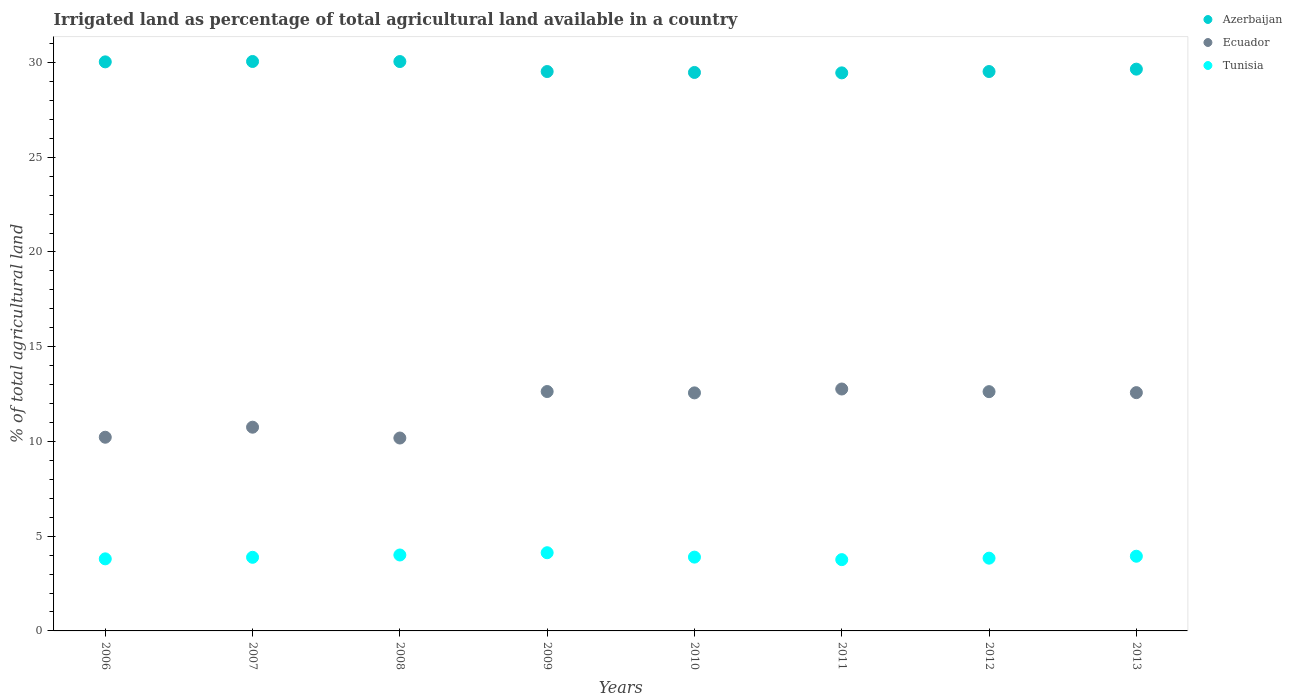How many different coloured dotlines are there?
Ensure brevity in your answer.  3. What is the percentage of irrigated land in Tunisia in 2006?
Your answer should be very brief. 3.8. Across all years, what is the maximum percentage of irrigated land in Azerbaijan?
Your answer should be very brief. 30.06. Across all years, what is the minimum percentage of irrigated land in Azerbaijan?
Your response must be concise. 29.45. What is the total percentage of irrigated land in Ecuador in the graph?
Your answer should be very brief. 94.33. What is the difference between the percentage of irrigated land in Azerbaijan in 2007 and that in 2010?
Provide a short and direct response. 0.58. What is the difference between the percentage of irrigated land in Tunisia in 2011 and the percentage of irrigated land in Ecuador in 2008?
Provide a succinct answer. -6.42. What is the average percentage of irrigated land in Ecuador per year?
Provide a succinct answer. 11.79. In the year 2013, what is the difference between the percentage of irrigated land in Tunisia and percentage of irrigated land in Ecuador?
Offer a terse response. -8.63. What is the ratio of the percentage of irrigated land in Azerbaijan in 2010 to that in 2011?
Ensure brevity in your answer.  1. Is the percentage of irrigated land in Azerbaijan in 2011 less than that in 2012?
Offer a terse response. Yes. What is the difference between the highest and the second highest percentage of irrigated land in Ecuador?
Keep it short and to the point. 0.13. What is the difference between the highest and the lowest percentage of irrigated land in Tunisia?
Give a very brief answer. 0.36. Is it the case that in every year, the sum of the percentage of irrigated land in Tunisia and percentage of irrigated land in Ecuador  is greater than the percentage of irrigated land in Azerbaijan?
Offer a terse response. No. Does the percentage of irrigated land in Azerbaijan monotonically increase over the years?
Your response must be concise. No. Is the percentage of irrigated land in Ecuador strictly greater than the percentage of irrigated land in Tunisia over the years?
Your answer should be compact. Yes. Is the percentage of irrigated land in Azerbaijan strictly less than the percentage of irrigated land in Tunisia over the years?
Your response must be concise. No. How many years are there in the graph?
Make the answer very short. 8. What is the difference between two consecutive major ticks on the Y-axis?
Keep it short and to the point. 5. Does the graph contain any zero values?
Make the answer very short. No. How many legend labels are there?
Provide a succinct answer. 3. How are the legend labels stacked?
Offer a very short reply. Vertical. What is the title of the graph?
Ensure brevity in your answer.  Irrigated land as percentage of total agricultural land available in a country. Does "Guatemala" appear as one of the legend labels in the graph?
Give a very brief answer. No. What is the label or title of the Y-axis?
Ensure brevity in your answer.  % of total agricultural land. What is the % of total agricultural land of Azerbaijan in 2006?
Offer a terse response. 30.04. What is the % of total agricultural land of Ecuador in 2006?
Provide a succinct answer. 10.22. What is the % of total agricultural land in Tunisia in 2006?
Make the answer very short. 3.8. What is the % of total agricultural land of Azerbaijan in 2007?
Keep it short and to the point. 30.06. What is the % of total agricultural land of Ecuador in 2007?
Your answer should be compact. 10.75. What is the % of total agricultural land in Tunisia in 2007?
Offer a terse response. 3.89. What is the % of total agricultural land in Azerbaijan in 2008?
Give a very brief answer. 30.05. What is the % of total agricultural land in Ecuador in 2008?
Ensure brevity in your answer.  10.18. What is the % of total agricultural land of Tunisia in 2008?
Offer a very short reply. 4.01. What is the % of total agricultural land in Azerbaijan in 2009?
Offer a very short reply. 29.53. What is the % of total agricultural land of Ecuador in 2009?
Provide a succinct answer. 12.64. What is the % of total agricultural land of Tunisia in 2009?
Provide a short and direct response. 4.13. What is the % of total agricultural land of Azerbaijan in 2010?
Offer a terse response. 29.48. What is the % of total agricultural land in Ecuador in 2010?
Offer a very short reply. 12.56. What is the % of total agricultural land of Tunisia in 2010?
Your answer should be very brief. 3.9. What is the % of total agricultural land of Azerbaijan in 2011?
Your response must be concise. 29.45. What is the % of total agricultural land of Ecuador in 2011?
Your answer should be very brief. 12.77. What is the % of total agricultural land of Tunisia in 2011?
Provide a short and direct response. 3.76. What is the % of total agricultural land of Azerbaijan in 2012?
Make the answer very short. 29.53. What is the % of total agricultural land of Ecuador in 2012?
Your answer should be compact. 12.63. What is the % of total agricultural land of Tunisia in 2012?
Ensure brevity in your answer.  3.84. What is the % of total agricultural land in Azerbaijan in 2013?
Provide a succinct answer. 29.65. What is the % of total agricultural land in Ecuador in 2013?
Give a very brief answer. 12.58. What is the % of total agricultural land in Tunisia in 2013?
Give a very brief answer. 3.94. Across all years, what is the maximum % of total agricultural land of Azerbaijan?
Your response must be concise. 30.06. Across all years, what is the maximum % of total agricultural land of Ecuador?
Offer a very short reply. 12.77. Across all years, what is the maximum % of total agricultural land of Tunisia?
Ensure brevity in your answer.  4.13. Across all years, what is the minimum % of total agricultural land in Azerbaijan?
Give a very brief answer. 29.45. Across all years, what is the minimum % of total agricultural land of Ecuador?
Your response must be concise. 10.18. Across all years, what is the minimum % of total agricultural land of Tunisia?
Your answer should be very brief. 3.76. What is the total % of total agricultural land of Azerbaijan in the graph?
Ensure brevity in your answer.  237.78. What is the total % of total agricultural land of Ecuador in the graph?
Provide a short and direct response. 94.33. What is the total % of total agricultural land in Tunisia in the graph?
Provide a succinct answer. 31.26. What is the difference between the % of total agricultural land of Azerbaijan in 2006 and that in 2007?
Offer a very short reply. -0.02. What is the difference between the % of total agricultural land in Ecuador in 2006 and that in 2007?
Ensure brevity in your answer.  -0.53. What is the difference between the % of total agricultural land of Tunisia in 2006 and that in 2007?
Keep it short and to the point. -0.08. What is the difference between the % of total agricultural land in Azerbaijan in 2006 and that in 2008?
Ensure brevity in your answer.  -0.02. What is the difference between the % of total agricultural land of Ecuador in 2006 and that in 2008?
Your response must be concise. 0.04. What is the difference between the % of total agricultural land of Tunisia in 2006 and that in 2008?
Offer a very short reply. -0.2. What is the difference between the % of total agricultural land of Azerbaijan in 2006 and that in 2009?
Give a very brief answer. 0.51. What is the difference between the % of total agricultural land of Ecuador in 2006 and that in 2009?
Offer a very short reply. -2.41. What is the difference between the % of total agricultural land in Tunisia in 2006 and that in 2009?
Give a very brief answer. -0.32. What is the difference between the % of total agricultural land of Azerbaijan in 2006 and that in 2010?
Keep it short and to the point. 0.56. What is the difference between the % of total agricultural land in Ecuador in 2006 and that in 2010?
Your answer should be compact. -2.34. What is the difference between the % of total agricultural land of Tunisia in 2006 and that in 2010?
Make the answer very short. -0.09. What is the difference between the % of total agricultural land in Azerbaijan in 2006 and that in 2011?
Give a very brief answer. 0.58. What is the difference between the % of total agricultural land in Ecuador in 2006 and that in 2011?
Your answer should be very brief. -2.55. What is the difference between the % of total agricultural land of Tunisia in 2006 and that in 2011?
Your answer should be very brief. 0.04. What is the difference between the % of total agricultural land of Azerbaijan in 2006 and that in 2012?
Offer a very short reply. 0.51. What is the difference between the % of total agricultural land in Ecuador in 2006 and that in 2012?
Give a very brief answer. -2.41. What is the difference between the % of total agricultural land of Tunisia in 2006 and that in 2012?
Ensure brevity in your answer.  -0.04. What is the difference between the % of total agricultural land in Azerbaijan in 2006 and that in 2013?
Your answer should be compact. 0.38. What is the difference between the % of total agricultural land of Ecuador in 2006 and that in 2013?
Your answer should be very brief. -2.35. What is the difference between the % of total agricultural land in Tunisia in 2006 and that in 2013?
Keep it short and to the point. -0.14. What is the difference between the % of total agricultural land in Azerbaijan in 2007 and that in 2008?
Offer a terse response. 0. What is the difference between the % of total agricultural land in Ecuador in 2007 and that in 2008?
Provide a short and direct response. 0.57. What is the difference between the % of total agricultural land of Tunisia in 2007 and that in 2008?
Your answer should be compact. -0.12. What is the difference between the % of total agricultural land of Azerbaijan in 2007 and that in 2009?
Your response must be concise. 0.53. What is the difference between the % of total agricultural land in Ecuador in 2007 and that in 2009?
Provide a short and direct response. -1.88. What is the difference between the % of total agricultural land in Tunisia in 2007 and that in 2009?
Ensure brevity in your answer.  -0.24. What is the difference between the % of total agricultural land of Azerbaijan in 2007 and that in 2010?
Ensure brevity in your answer.  0.58. What is the difference between the % of total agricultural land in Ecuador in 2007 and that in 2010?
Offer a very short reply. -1.81. What is the difference between the % of total agricultural land of Tunisia in 2007 and that in 2010?
Your answer should be very brief. -0.01. What is the difference between the % of total agricultural land of Azerbaijan in 2007 and that in 2011?
Your answer should be very brief. 0.6. What is the difference between the % of total agricultural land in Ecuador in 2007 and that in 2011?
Your response must be concise. -2.02. What is the difference between the % of total agricultural land of Tunisia in 2007 and that in 2011?
Ensure brevity in your answer.  0.12. What is the difference between the % of total agricultural land in Azerbaijan in 2007 and that in 2012?
Your answer should be very brief. 0.53. What is the difference between the % of total agricultural land of Ecuador in 2007 and that in 2012?
Provide a short and direct response. -1.88. What is the difference between the % of total agricultural land of Tunisia in 2007 and that in 2012?
Make the answer very short. 0.05. What is the difference between the % of total agricultural land in Azerbaijan in 2007 and that in 2013?
Provide a succinct answer. 0.4. What is the difference between the % of total agricultural land in Ecuador in 2007 and that in 2013?
Offer a very short reply. -1.82. What is the difference between the % of total agricultural land of Tunisia in 2007 and that in 2013?
Offer a terse response. -0.06. What is the difference between the % of total agricultural land in Azerbaijan in 2008 and that in 2009?
Provide a succinct answer. 0.53. What is the difference between the % of total agricultural land in Ecuador in 2008 and that in 2009?
Offer a very short reply. -2.45. What is the difference between the % of total agricultural land of Tunisia in 2008 and that in 2009?
Provide a short and direct response. -0.12. What is the difference between the % of total agricultural land in Azerbaijan in 2008 and that in 2010?
Keep it short and to the point. 0.58. What is the difference between the % of total agricultural land in Ecuador in 2008 and that in 2010?
Your answer should be very brief. -2.38. What is the difference between the % of total agricultural land of Tunisia in 2008 and that in 2010?
Make the answer very short. 0.11. What is the difference between the % of total agricultural land in Azerbaijan in 2008 and that in 2011?
Ensure brevity in your answer.  0.6. What is the difference between the % of total agricultural land of Ecuador in 2008 and that in 2011?
Your answer should be very brief. -2.59. What is the difference between the % of total agricultural land of Tunisia in 2008 and that in 2011?
Provide a short and direct response. 0.24. What is the difference between the % of total agricultural land of Azerbaijan in 2008 and that in 2012?
Ensure brevity in your answer.  0.53. What is the difference between the % of total agricultural land in Ecuador in 2008 and that in 2012?
Your answer should be very brief. -2.45. What is the difference between the % of total agricultural land of Tunisia in 2008 and that in 2012?
Give a very brief answer. 0.17. What is the difference between the % of total agricultural land of Azerbaijan in 2008 and that in 2013?
Give a very brief answer. 0.4. What is the difference between the % of total agricultural land of Ecuador in 2008 and that in 2013?
Offer a terse response. -2.4. What is the difference between the % of total agricultural land in Tunisia in 2008 and that in 2013?
Provide a short and direct response. 0.07. What is the difference between the % of total agricultural land in Azerbaijan in 2009 and that in 2010?
Ensure brevity in your answer.  0.05. What is the difference between the % of total agricultural land of Ecuador in 2009 and that in 2010?
Keep it short and to the point. 0.07. What is the difference between the % of total agricultural land of Tunisia in 2009 and that in 2010?
Ensure brevity in your answer.  0.23. What is the difference between the % of total agricultural land of Azerbaijan in 2009 and that in 2011?
Offer a terse response. 0.07. What is the difference between the % of total agricultural land in Ecuador in 2009 and that in 2011?
Offer a very short reply. -0.13. What is the difference between the % of total agricultural land of Tunisia in 2009 and that in 2011?
Your answer should be compact. 0.36. What is the difference between the % of total agricultural land of Azerbaijan in 2009 and that in 2012?
Keep it short and to the point. -0. What is the difference between the % of total agricultural land in Ecuador in 2009 and that in 2012?
Make the answer very short. 0.01. What is the difference between the % of total agricultural land in Tunisia in 2009 and that in 2012?
Your answer should be very brief. 0.29. What is the difference between the % of total agricultural land of Azerbaijan in 2009 and that in 2013?
Ensure brevity in your answer.  -0.13. What is the difference between the % of total agricultural land of Ecuador in 2009 and that in 2013?
Make the answer very short. 0.06. What is the difference between the % of total agricultural land in Tunisia in 2009 and that in 2013?
Your answer should be compact. 0.18. What is the difference between the % of total agricultural land in Azerbaijan in 2010 and that in 2011?
Provide a short and direct response. 0.02. What is the difference between the % of total agricultural land in Ecuador in 2010 and that in 2011?
Your response must be concise. -0.2. What is the difference between the % of total agricultural land of Tunisia in 2010 and that in 2011?
Your answer should be compact. 0.13. What is the difference between the % of total agricultural land of Azerbaijan in 2010 and that in 2012?
Make the answer very short. -0.05. What is the difference between the % of total agricultural land of Ecuador in 2010 and that in 2012?
Provide a short and direct response. -0.06. What is the difference between the % of total agricultural land in Tunisia in 2010 and that in 2012?
Make the answer very short. 0.06. What is the difference between the % of total agricultural land in Azerbaijan in 2010 and that in 2013?
Offer a very short reply. -0.17. What is the difference between the % of total agricultural land in Ecuador in 2010 and that in 2013?
Ensure brevity in your answer.  -0.01. What is the difference between the % of total agricultural land in Tunisia in 2010 and that in 2013?
Offer a very short reply. -0.05. What is the difference between the % of total agricultural land in Azerbaijan in 2011 and that in 2012?
Make the answer very short. -0.07. What is the difference between the % of total agricultural land of Ecuador in 2011 and that in 2012?
Your answer should be compact. 0.14. What is the difference between the % of total agricultural land in Tunisia in 2011 and that in 2012?
Keep it short and to the point. -0.08. What is the difference between the % of total agricultural land of Azerbaijan in 2011 and that in 2013?
Make the answer very short. -0.2. What is the difference between the % of total agricultural land of Ecuador in 2011 and that in 2013?
Ensure brevity in your answer.  0.19. What is the difference between the % of total agricultural land in Tunisia in 2011 and that in 2013?
Give a very brief answer. -0.18. What is the difference between the % of total agricultural land in Azerbaijan in 2012 and that in 2013?
Your answer should be very brief. -0.12. What is the difference between the % of total agricultural land in Ecuador in 2012 and that in 2013?
Your answer should be very brief. 0.05. What is the difference between the % of total agricultural land of Tunisia in 2012 and that in 2013?
Your response must be concise. -0.1. What is the difference between the % of total agricultural land of Azerbaijan in 2006 and the % of total agricultural land of Ecuador in 2007?
Your answer should be very brief. 19.28. What is the difference between the % of total agricultural land in Azerbaijan in 2006 and the % of total agricultural land in Tunisia in 2007?
Give a very brief answer. 26.15. What is the difference between the % of total agricultural land in Ecuador in 2006 and the % of total agricultural land in Tunisia in 2007?
Your response must be concise. 6.34. What is the difference between the % of total agricultural land of Azerbaijan in 2006 and the % of total agricultural land of Ecuador in 2008?
Ensure brevity in your answer.  19.85. What is the difference between the % of total agricultural land in Azerbaijan in 2006 and the % of total agricultural land in Tunisia in 2008?
Offer a terse response. 26.03. What is the difference between the % of total agricultural land in Ecuador in 2006 and the % of total agricultural land in Tunisia in 2008?
Offer a terse response. 6.22. What is the difference between the % of total agricultural land of Azerbaijan in 2006 and the % of total agricultural land of Ecuador in 2009?
Your response must be concise. 17.4. What is the difference between the % of total agricultural land in Azerbaijan in 2006 and the % of total agricultural land in Tunisia in 2009?
Offer a very short reply. 25.91. What is the difference between the % of total agricultural land of Ecuador in 2006 and the % of total agricultural land of Tunisia in 2009?
Provide a succinct answer. 6.1. What is the difference between the % of total agricultural land of Azerbaijan in 2006 and the % of total agricultural land of Ecuador in 2010?
Keep it short and to the point. 17.47. What is the difference between the % of total agricultural land in Azerbaijan in 2006 and the % of total agricultural land in Tunisia in 2010?
Provide a short and direct response. 26.14. What is the difference between the % of total agricultural land of Ecuador in 2006 and the % of total agricultural land of Tunisia in 2010?
Make the answer very short. 6.33. What is the difference between the % of total agricultural land in Azerbaijan in 2006 and the % of total agricultural land in Ecuador in 2011?
Provide a succinct answer. 17.27. What is the difference between the % of total agricultural land in Azerbaijan in 2006 and the % of total agricultural land in Tunisia in 2011?
Offer a terse response. 26.27. What is the difference between the % of total agricultural land of Ecuador in 2006 and the % of total agricultural land of Tunisia in 2011?
Provide a succinct answer. 6.46. What is the difference between the % of total agricultural land in Azerbaijan in 2006 and the % of total agricultural land in Ecuador in 2012?
Your answer should be very brief. 17.41. What is the difference between the % of total agricultural land in Azerbaijan in 2006 and the % of total agricultural land in Tunisia in 2012?
Your answer should be compact. 26.2. What is the difference between the % of total agricultural land of Ecuador in 2006 and the % of total agricultural land of Tunisia in 2012?
Offer a very short reply. 6.38. What is the difference between the % of total agricultural land in Azerbaijan in 2006 and the % of total agricultural land in Ecuador in 2013?
Your answer should be compact. 17.46. What is the difference between the % of total agricultural land in Azerbaijan in 2006 and the % of total agricultural land in Tunisia in 2013?
Your answer should be compact. 26.09. What is the difference between the % of total agricultural land of Ecuador in 2006 and the % of total agricultural land of Tunisia in 2013?
Keep it short and to the point. 6.28. What is the difference between the % of total agricultural land in Azerbaijan in 2007 and the % of total agricultural land in Ecuador in 2008?
Make the answer very short. 19.87. What is the difference between the % of total agricultural land in Azerbaijan in 2007 and the % of total agricultural land in Tunisia in 2008?
Keep it short and to the point. 26.05. What is the difference between the % of total agricultural land in Ecuador in 2007 and the % of total agricultural land in Tunisia in 2008?
Give a very brief answer. 6.75. What is the difference between the % of total agricultural land of Azerbaijan in 2007 and the % of total agricultural land of Ecuador in 2009?
Provide a succinct answer. 17.42. What is the difference between the % of total agricultural land in Azerbaijan in 2007 and the % of total agricultural land in Tunisia in 2009?
Your answer should be very brief. 25.93. What is the difference between the % of total agricultural land of Ecuador in 2007 and the % of total agricultural land of Tunisia in 2009?
Give a very brief answer. 6.63. What is the difference between the % of total agricultural land in Azerbaijan in 2007 and the % of total agricultural land in Ecuador in 2010?
Keep it short and to the point. 17.49. What is the difference between the % of total agricultural land in Azerbaijan in 2007 and the % of total agricultural land in Tunisia in 2010?
Provide a succinct answer. 26.16. What is the difference between the % of total agricultural land of Ecuador in 2007 and the % of total agricultural land of Tunisia in 2010?
Offer a very short reply. 6.86. What is the difference between the % of total agricultural land in Azerbaijan in 2007 and the % of total agricultural land in Ecuador in 2011?
Offer a very short reply. 17.29. What is the difference between the % of total agricultural land in Azerbaijan in 2007 and the % of total agricultural land in Tunisia in 2011?
Your answer should be compact. 26.29. What is the difference between the % of total agricultural land of Ecuador in 2007 and the % of total agricultural land of Tunisia in 2011?
Your answer should be compact. 6.99. What is the difference between the % of total agricultural land in Azerbaijan in 2007 and the % of total agricultural land in Ecuador in 2012?
Make the answer very short. 17.43. What is the difference between the % of total agricultural land in Azerbaijan in 2007 and the % of total agricultural land in Tunisia in 2012?
Provide a succinct answer. 26.22. What is the difference between the % of total agricultural land in Ecuador in 2007 and the % of total agricultural land in Tunisia in 2012?
Make the answer very short. 6.91. What is the difference between the % of total agricultural land in Azerbaijan in 2007 and the % of total agricultural land in Ecuador in 2013?
Ensure brevity in your answer.  17.48. What is the difference between the % of total agricultural land of Azerbaijan in 2007 and the % of total agricultural land of Tunisia in 2013?
Offer a very short reply. 26.11. What is the difference between the % of total agricultural land in Ecuador in 2007 and the % of total agricultural land in Tunisia in 2013?
Offer a terse response. 6.81. What is the difference between the % of total agricultural land of Azerbaijan in 2008 and the % of total agricultural land of Ecuador in 2009?
Give a very brief answer. 17.42. What is the difference between the % of total agricultural land of Azerbaijan in 2008 and the % of total agricultural land of Tunisia in 2009?
Your response must be concise. 25.93. What is the difference between the % of total agricultural land of Ecuador in 2008 and the % of total agricultural land of Tunisia in 2009?
Offer a very short reply. 6.05. What is the difference between the % of total agricultural land of Azerbaijan in 2008 and the % of total agricultural land of Ecuador in 2010?
Provide a succinct answer. 17.49. What is the difference between the % of total agricultural land in Azerbaijan in 2008 and the % of total agricultural land in Tunisia in 2010?
Offer a terse response. 26.16. What is the difference between the % of total agricultural land of Ecuador in 2008 and the % of total agricultural land of Tunisia in 2010?
Offer a very short reply. 6.29. What is the difference between the % of total agricultural land of Azerbaijan in 2008 and the % of total agricultural land of Ecuador in 2011?
Make the answer very short. 17.28. What is the difference between the % of total agricultural land in Azerbaijan in 2008 and the % of total agricultural land in Tunisia in 2011?
Keep it short and to the point. 26.29. What is the difference between the % of total agricultural land in Ecuador in 2008 and the % of total agricultural land in Tunisia in 2011?
Keep it short and to the point. 6.42. What is the difference between the % of total agricultural land in Azerbaijan in 2008 and the % of total agricultural land in Ecuador in 2012?
Offer a very short reply. 17.42. What is the difference between the % of total agricultural land in Azerbaijan in 2008 and the % of total agricultural land in Tunisia in 2012?
Offer a terse response. 26.21. What is the difference between the % of total agricultural land in Ecuador in 2008 and the % of total agricultural land in Tunisia in 2012?
Make the answer very short. 6.34. What is the difference between the % of total agricultural land in Azerbaijan in 2008 and the % of total agricultural land in Ecuador in 2013?
Ensure brevity in your answer.  17.48. What is the difference between the % of total agricultural land of Azerbaijan in 2008 and the % of total agricultural land of Tunisia in 2013?
Keep it short and to the point. 26.11. What is the difference between the % of total agricultural land in Ecuador in 2008 and the % of total agricultural land in Tunisia in 2013?
Make the answer very short. 6.24. What is the difference between the % of total agricultural land of Azerbaijan in 2009 and the % of total agricultural land of Ecuador in 2010?
Ensure brevity in your answer.  16.96. What is the difference between the % of total agricultural land of Azerbaijan in 2009 and the % of total agricultural land of Tunisia in 2010?
Provide a succinct answer. 25.63. What is the difference between the % of total agricultural land in Ecuador in 2009 and the % of total agricultural land in Tunisia in 2010?
Your answer should be very brief. 8.74. What is the difference between the % of total agricultural land of Azerbaijan in 2009 and the % of total agricultural land of Ecuador in 2011?
Give a very brief answer. 16.76. What is the difference between the % of total agricultural land of Azerbaijan in 2009 and the % of total agricultural land of Tunisia in 2011?
Your answer should be compact. 25.76. What is the difference between the % of total agricultural land of Ecuador in 2009 and the % of total agricultural land of Tunisia in 2011?
Your response must be concise. 8.87. What is the difference between the % of total agricultural land in Azerbaijan in 2009 and the % of total agricultural land in Ecuador in 2012?
Your answer should be very brief. 16.9. What is the difference between the % of total agricultural land of Azerbaijan in 2009 and the % of total agricultural land of Tunisia in 2012?
Offer a terse response. 25.69. What is the difference between the % of total agricultural land in Ecuador in 2009 and the % of total agricultural land in Tunisia in 2012?
Offer a terse response. 8.8. What is the difference between the % of total agricultural land in Azerbaijan in 2009 and the % of total agricultural land in Ecuador in 2013?
Offer a terse response. 16.95. What is the difference between the % of total agricultural land of Azerbaijan in 2009 and the % of total agricultural land of Tunisia in 2013?
Offer a terse response. 25.58. What is the difference between the % of total agricultural land of Ecuador in 2009 and the % of total agricultural land of Tunisia in 2013?
Your response must be concise. 8.69. What is the difference between the % of total agricultural land of Azerbaijan in 2010 and the % of total agricultural land of Ecuador in 2011?
Your answer should be compact. 16.71. What is the difference between the % of total agricultural land in Azerbaijan in 2010 and the % of total agricultural land in Tunisia in 2011?
Your response must be concise. 25.71. What is the difference between the % of total agricultural land in Ecuador in 2010 and the % of total agricultural land in Tunisia in 2011?
Your answer should be very brief. 8.8. What is the difference between the % of total agricultural land in Azerbaijan in 2010 and the % of total agricultural land in Ecuador in 2012?
Keep it short and to the point. 16.85. What is the difference between the % of total agricultural land of Azerbaijan in 2010 and the % of total agricultural land of Tunisia in 2012?
Make the answer very short. 25.64. What is the difference between the % of total agricultural land of Ecuador in 2010 and the % of total agricultural land of Tunisia in 2012?
Your answer should be compact. 8.72. What is the difference between the % of total agricultural land in Azerbaijan in 2010 and the % of total agricultural land in Ecuador in 2013?
Your answer should be compact. 16.9. What is the difference between the % of total agricultural land in Azerbaijan in 2010 and the % of total agricultural land in Tunisia in 2013?
Your response must be concise. 25.53. What is the difference between the % of total agricultural land of Ecuador in 2010 and the % of total agricultural land of Tunisia in 2013?
Offer a terse response. 8.62. What is the difference between the % of total agricultural land of Azerbaijan in 2011 and the % of total agricultural land of Ecuador in 2012?
Offer a very short reply. 16.83. What is the difference between the % of total agricultural land in Azerbaijan in 2011 and the % of total agricultural land in Tunisia in 2012?
Give a very brief answer. 25.61. What is the difference between the % of total agricultural land of Ecuador in 2011 and the % of total agricultural land of Tunisia in 2012?
Offer a terse response. 8.93. What is the difference between the % of total agricultural land in Azerbaijan in 2011 and the % of total agricultural land in Ecuador in 2013?
Ensure brevity in your answer.  16.88. What is the difference between the % of total agricultural land of Azerbaijan in 2011 and the % of total agricultural land of Tunisia in 2013?
Offer a very short reply. 25.51. What is the difference between the % of total agricultural land of Ecuador in 2011 and the % of total agricultural land of Tunisia in 2013?
Offer a terse response. 8.83. What is the difference between the % of total agricultural land of Azerbaijan in 2012 and the % of total agricultural land of Ecuador in 2013?
Provide a short and direct response. 16.95. What is the difference between the % of total agricultural land of Azerbaijan in 2012 and the % of total agricultural land of Tunisia in 2013?
Your answer should be very brief. 25.58. What is the difference between the % of total agricultural land in Ecuador in 2012 and the % of total agricultural land in Tunisia in 2013?
Your response must be concise. 8.69. What is the average % of total agricultural land of Azerbaijan per year?
Your response must be concise. 29.72. What is the average % of total agricultural land in Ecuador per year?
Offer a terse response. 11.79. What is the average % of total agricultural land in Tunisia per year?
Provide a short and direct response. 3.91. In the year 2006, what is the difference between the % of total agricultural land in Azerbaijan and % of total agricultural land in Ecuador?
Your response must be concise. 19.81. In the year 2006, what is the difference between the % of total agricultural land in Azerbaijan and % of total agricultural land in Tunisia?
Give a very brief answer. 26.23. In the year 2006, what is the difference between the % of total agricultural land in Ecuador and % of total agricultural land in Tunisia?
Your answer should be compact. 6.42. In the year 2007, what is the difference between the % of total agricultural land in Azerbaijan and % of total agricultural land in Ecuador?
Offer a very short reply. 19.3. In the year 2007, what is the difference between the % of total agricultural land in Azerbaijan and % of total agricultural land in Tunisia?
Provide a short and direct response. 26.17. In the year 2007, what is the difference between the % of total agricultural land of Ecuador and % of total agricultural land of Tunisia?
Provide a succinct answer. 6.87. In the year 2008, what is the difference between the % of total agricultural land in Azerbaijan and % of total agricultural land in Ecuador?
Offer a terse response. 19.87. In the year 2008, what is the difference between the % of total agricultural land of Azerbaijan and % of total agricultural land of Tunisia?
Make the answer very short. 26.04. In the year 2008, what is the difference between the % of total agricultural land in Ecuador and % of total agricultural land in Tunisia?
Give a very brief answer. 6.17. In the year 2009, what is the difference between the % of total agricultural land in Azerbaijan and % of total agricultural land in Ecuador?
Give a very brief answer. 16.89. In the year 2009, what is the difference between the % of total agricultural land in Azerbaijan and % of total agricultural land in Tunisia?
Offer a very short reply. 25.4. In the year 2009, what is the difference between the % of total agricultural land in Ecuador and % of total agricultural land in Tunisia?
Offer a very short reply. 8.51. In the year 2010, what is the difference between the % of total agricultural land in Azerbaijan and % of total agricultural land in Ecuador?
Offer a terse response. 16.91. In the year 2010, what is the difference between the % of total agricultural land of Azerbaijan and % of total agricultural land of Tunisia?
Your answer should be very brief. 25.58. In the year 2010, what is the difference between the % of total agricultural land of Ecuador and % of total agricultural land of Tunisia?
Your answer should be compact. 8.67. In the year 2011, what is the difference between the % of total agricultural land of Azerbaijan and % of total agricultural land of Ecuador?
Ensure brevity in your answer.  16.69. In the year 2011, what is the difference between the % of total agricultural land of Azerbaijan and % of total agricultural land of Tunisia?
Offer a terse response. 25.69. In the year 2011, what is the difference between the % of total agricultural land in Ecuador and % of total agricultural land in Tunisia?
Keep it short and to the point. 9.01. In the year 2012, what is the difference between the % of total agricultural land in Azerbaijan and % of total agricultural land in Ecuador?
Offer a terse response. 16.9. In the year 2012, what is the difference between the % of total agricultural land of Azerbaijan and % of total agricultural land of Tunisia?
Your answer should be very brief. 25.69. In the year 2012, what is the difference between the % of total agricultural land of Ecuador and % of total agricultural land of Tunisia?
Your answer should be compact. 8.79. In the year 2013, what is the difference between the % of total agricultural land in Azerbaijan and % of total agricultural land in Ecuador?
Your response must be concise. 17.07. In the year 2013, what is the difference between the % of total agricultural land of Azerbaijan and % of total agricultural land of Tunisia?
Your response must be concise. 25.71. In the year 2013, what is the difference between the % of total agricultural land of Ecuador and % of total agricultural land of Tunisia?
Provide a short and direct response. 8.63. What is the ratio of the % of total agricultural land in Ecuador in 2006 to that in 2007?
Make the answer very short. 0.95. What is the ratio of the % of total agricultural land in Tunisia in 2006 to that in 2007?
Your answer should be compact. 0.98. What is the ratio of the % of total agricultural land of Azerbaijan in 2006 to that in 2008?
Provide a short and direct response. 1. What is the ratio of the % of total agricultural land in Ecuador in 2006 to that in 2008?
Give a very brief answer. 1. What is the ratio of the % of total agricultural land in Tunisia in 2006 to that in 2008?
Your answer should be compact. 0.95. What is the ratio of the % of total agricultural land in Azerbaijan in 2006 to that in 2009?
Give a very brief answer. 1.02. What is the ratio of the % of total agricultural land of Ecuador in 2006 to that in 2009?
Provide a succinct answer. 0.81. What is the ratio of the % of total agricultural land in Tunisia in 2006 to that in 2009?
Give a very brief answer. 0.92. What is the ratio of the % of total agricultural land in Ecuador in 2006 to that in 2010?
Your answer should be very brief. 0.81. What is the ratio of the % of total agricultural land of Tunisia in 2006 to that in 2010?
Offer a terse response. 0.98. What is the ratio of the % of total agricultural land of Azerbaijan in 2006 to that in 2011?
Offer a terse response. 1.02. What is the ratio of the % of total agricultural land in Ecuador in 2006 to that in 2011?
Your response must be concise. 0.8. What is the ratio of the % of total agricultural land of Tunisia in 2006 to that in 2011?
Your response must be concise. 1.01. What is the ratio of the % of total agricultural land of Azerbaijan in 2006 to that in 2012?
Provide a succinct answer. 1.02. What is the ratio of the % of total agricultural land in Ecuador in 2006 to that in 2012?
Offer a terse response. 0.81. What is the ratio of the % of total agricultural land in Tunisia in 2006 to that in 2012?
Keep it short and to the point. 0.99. What is the ratio of the % of total agricultural land in Azerbaijan in 2006 to that in 2013?
Provide a short and direct response. 1.01. What is the ratio of the % of total agricultural land of Ecuador in 2006 to that in 2013?
Your response must be concise. 0.81. What is the ratio of the % of total agricultural land of Tunisia in 2006 to that in 2013?
Your answer should be very brief. 0.96. What is the ratio of the % of total agricultural land of Azerbaijan in 2007 to that in 2008?
Keep it short and to the point. 1. What is the ratio of the % of total agricultural land in Ecuador in 2007 to that in 2008?
Provide a short and direct response. 1.06. What is the ratio of the % of total agricultural land of Tunisia in 2007 to that in 2008?
Your answer should be very brief. 0.97. What is the ratio of the % of total agricultural land in Azerbaijan in 2007 to that in 2009?
Offer a very short reply. 1.02. What is the ratio of the % of total agricultural land in Ecuador in 2007 to that in 2009?
Offer a very short reply. 0.85. What is the ratio of the % of total agricultural land of Tunisia in 2007 to that in 2009?
Keep it short and to the point. 0.94. What is the ratio of the % of total agricultural land of Azerbaijan in 2007 to that in 2010?
Provide a succinct answer. 1.02. What is the ratio of the % of total agricultural land of Ecuador in 2007 to that in 2010?
Offer a very short reply. 0.86. What is the ratio of the % of total agricultural land in Tunisia in 2007 to that in 2010?
Ensure brevity in your answer.  1. What is the ratio of the % of total agricultural land in Azerbaijan in 2007 to that in 2011?
Offer a terse response. 1.02. What is the ratio of the % of total agricultural land of Ecuador in 2007 to that in 2011?
Keep it short and to the point. 0.84. What is the ratio of the % of total agricultural land of Tunisia in 2007 to that in 2011?
Give a very brief answer. 1.03. What is the ratio of the % of total agricultural land of Azerbaijan in 2007 to that in 2012?
Provide a short and direct response. 1.02. What is the ratio of the % of total agricultural land of Ecuador in 2007 to that in 2012?
Your response must be concise. 0.85. What is the ratio of the % of total agricultural land of Tunisia in 2007 to that in 2012?
Make the answer very short. 1.01. What is the ratio of the % of total agricultural land in Azerbaijan in 2007 to that in 2013?
Provide a short and direct response. 1.01. What is the ratio of the % of total agricultural land in Ecuador in 2007 to that in 2013?
Provide a short and direct response. 0.85. What is the ratio of the % of total agricultural land of Tunisia in 2007 to that in 2013?
Offer a terse response. 0.99. What is the ratio of the % of total agricultural land of Azerbaijan in 2008 to that in 2009?
Provide a short and direct response. 1.02. What is the ratio of the % of total agricultural land of Ecuador in 2008 to that in 2009?
Keep it short and to the point. 0.81. What is the ratio of the % of total agricultural land in Tunisia in 2008 to that in 2009?
Ensure brevity in your answer.  0.97. What is the ratio of the % of total agricultural land of Azerbaijan in 2008 to that in 2010?
Provide a succinct answer. 1.02. What is the ratio of the % of total agricultural land in Ecuador in 2008 to that in 2010?
Ensure brevity in your answer.  0.81. What is the ratio of the % of total agricultural land of Tunisia in 2008 to that in 2010?
Provide a succinct answer. 1.03. What is the ratio of the % of total agricultural land of Azerbaijan in 2008 to that in 2011?
Your response must be concise. 1.02. What is the ratio of the % of total agricultural land in Ecuador in 2008 to that in 2011?
Ensure brevity in your answer.  0.8. What is the ratio of the % of total agricultural land of Tunisia in 2008 to that in 2011?
Provide a short and direct response. 1.07. What is the ratio of the % of total agricultural land in Azerbaijan in 2008 to that in 2012?
Provide a short and direct response. 1.02. What is the ratio of the % of total agricultural land in Ecuador in 2008 to that in 2012?
Your response must be concise. 0.81. What is the ratio of the % of total agricultural land of Tunisia in 2008 to that in 2012?
Your answer should be compact. 1.04. What is the ratio of the % of total agricultural land of Azerbaijan in 2008 to that in 2013?
Your answer should be compact. 1.01. What is the ratio of the % of total agricultural land of Ecuador in 2008 to that in 2013?
Provide a short and direct response. 0.81. What is the ratio of the % of total agricultural land in Tunisia in 2008 to that in 2013?
Your answer should be compact. 1.02. What is the ratio of the % of total agricultural land of Azerbaijan in 2009 to that in 2010?
Provide a short and direct response. 1. What is the ratio of the % of total agricultural land in Tunisia in 2009 to that in 2010?
Make the answer very short. 1.06. What is the ratio of the % of total agricultural land in Azerbaijan in 2009 to that in 2011?
Your answer should be very brief. 1. What is the ratio of the % of total agricultural land in Tunisia in 2009 to that in 2011?
Your answer should be very brief. 1.1. What is the ratio of the % of total agricultural land in Azerbaijan in 2009 to that in 2012?
Offer a terse response. 1. What is the ratio of the % of total agricultural land in Tunisia in 2009 to that in 2012?
Your answer should be very brief. 1.07. What is the ratio of the % of total agricultural land in Ecuador in 2009 to that in 2013?
Ensure brevity in your answer.  1. What is the ratio of the % of total agricultural land of Tunisia in 2009 to that in 2013?
Ensure brevity in your answer.  1.05. What is the ratio of the % of total agricultural land in Azerbaijan in 2010 to that in 2011?
Make the answer very short. 1. What is the ratio of the % of total agricultural land of Tunisia in 2010 to that in 2011?
Make the answer very short. 1.04. What is the ratio of the % of total agricultural land in Azerbaijan in 2010 to that in 2012?
Your answer should be very brief. 1. What is the ratio of the % of total agricultural land of Tunisia in 2010 to that in 2012?
Your response must be concise. 1.01. What is the ratio of the % of total agricultural land in Azerbaijan in 2011 to that in 2012?
Your answer should be compact. 1. What is the ratio of the % of total agricultural land in Ecuador in 2011 to that in 2012?
Keep it short and to the point. 1.01. What is the ratio of the % of total agricultural land in Tunisia in 2011 to that in 2012?
Your response must be concise. 0.98. What is the ratio of the % of total agricultural land of Azerbaijan in 2011 to that in 2013?
Your response must be concise. 0.99. What is the ratio of the % of total agricultural land in Ecuador in 2011 to that in 2013?
Provide a short and direct response. 1.02. What is the ratio of the % of total agricultural land in Tunisia in 2011 to that in 2013?
Offer a very short reply. 0.95. What is the ratio of the % of total agricultural land of Ecuador in 2012 to that in 2013?
Your answer should be very brief. 1. What is the ratio of the % of total agricultural land in Tunisia in 2012 to that in 2013?
Your answer should be very brief. 0.97. What is the difference between the highest and the second highest % of total agricultural land in Azerbaijan?
Ensure brevity in your answer.  0. What is the difference between the highest and the second highest % of total agricultural land of Ecuador?
Provide a succinct answer. 0.13. What is the difference between the highest and the second highest % of total agricultural land in Tunisia?
Give a very brief answer. 0.12. What is the difference between the highest and the lowest % of total agricultural land of Azerbaijan?
Your answer should be very brief. 0.6. What is the difference between the highest and the lowest % of total agricultural land of Ecuador?
Provide a succinct answer. 2.59. What is the difference between the highest and the lowest % of total agricultural land of Tunisia?
Provide a short and direct response. 0.36. 